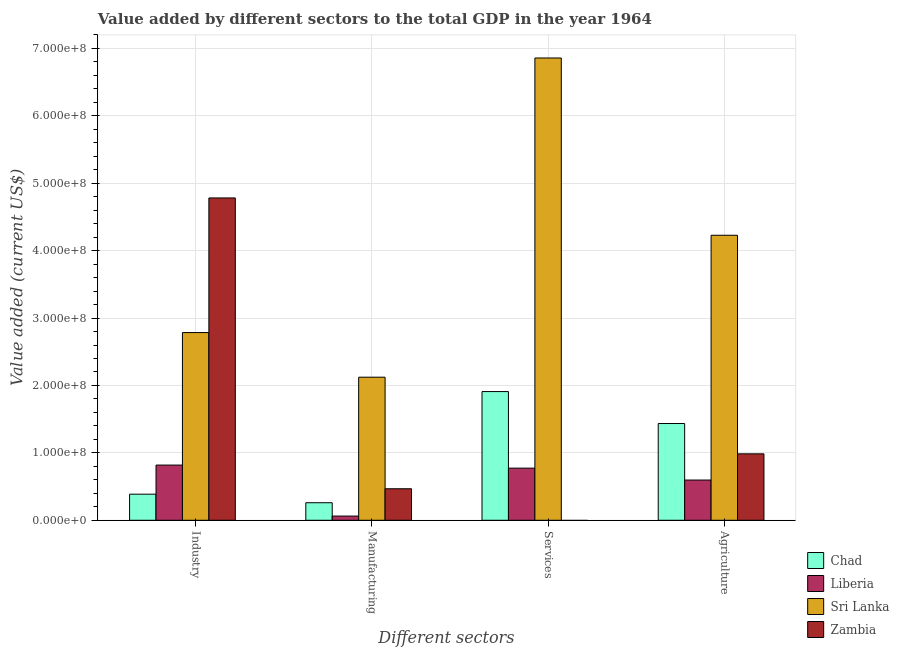How many different coloured bars are there?
Make the answer very short. 4. Are the number of bars per tick equal to the number of legend labels?
Keep it short and to the point. No. Are the number of bars on each tick of the X-axis equal?
Make the answer very short. No. How many bars are there on the 4th tick from the left?
Provide a short and direct response. 4. What is the label of the 1st group of bars from the left?
Your response must be concise. Industry. What is the value added by services sector in Zambia?
Your response must be concise. 0. Across all countries, what is the maximum value added by industrial sector?
Ensure brevity in your answer.  4.78e+08. Across all countries, what is the minimum value added by manufacturing sector?
Your response must be concise. 6.23e+06. In which country was the value added by industrial sector maximum?
Give a very brief answer. Zambia. What is the total value added by services sector in the graph?
Offer a very short reply. 9.54e+08. What is the difference between the value added by agricultural sector in Zambia and that in Chad?
Provide a short and direct response. -4.50e+07. What is the difference between the value added by services sector in Chad and the value added by manufacturing sector in Zambia?
Your answer should be very brief. 1.44e+08. What is the average value added by manufacturing sector per country?
Offer a very short reply. 7.28e+07. What is the difference between the value added by manufacturing sector and value added by industrial sector in Liberia?
Your response must be concise. -7.57e+07. What is the ratio of the value added by agricultural sector in Liberia to that in Zambia?
Offer a terse response. 0.61. Is the value added by agricultural sector in Sri Lanka less than that in Liberia?
Provide a short and direct response. No. What is the difference between the highest and the second highest value added by agricultural sector?
Offer a terse response. 2.79e+08. What is the difference between the highest and the lowest value added by manufacturing sector?
Give a very brief answer. 2.06e+08. In how many countries, is the value added by services sector greater than the average value added by services sector taken over all countries?
Your answer should be very brief. 1. Is the sum of the value added by agricultural sector in Chad and Sri Lanka greater than the maximum value added by manufacturing sector across all countries?
Ensure brevity in your answer.  Yes. Is it the case that in every country, the sum of the value added by industrial sector and value added by agricultural sector is greater than the sum of value added by services sector and value added by manufacturing sector?
Your answer should be very brief. No. How many bars are there?
Provide a short and direct response. 15. Are all the bars in the graph horizontal?
Give a very brief answer. No. Does the graph contain grids?
Offer a terse response. Yes. Where does the legend appear in the graph?
Provide a short and direct response. Bottom right. What is the title of the graph?
Your answer should be compact. Value added by different sectors to the total GDP in the year 1964. What is the label or title of the X-axis?
Give a very brief answer. Different sectors. What is the label or title of the Y-axis?
Your answer should be compact. Value added (current US$). What is the Value added (current US$) of Chad in Industry?
Your answer should be compact. 3.87e+07. What is the Value added (current US$) of Liberia in Industry?
Offer a very short reply. 8.19e+07. What is the Value added (current US$) of Sri Lanka in Industry?
Provide a succinct answer. 2.78e+08. What is the Value added (current US$) of Zambia in Industry?
Offer a terse response. 4.78e+08. What is the Value added (current US$) of Chad in Manufacturing?
Your answer should be compact. 2.60e+07. What is the Value added (current US$) of Liberia in Manufacturing?
Ensure brevity in your answer.  6.23e+06. What is the Value added (current US$) of Sri Lanka in Manufacturing?
Give a very brief answer. 2.12e+08. What is the Value added (current US$) of Zambia in Manufacturing?
Offer a terse response. 4.68e+07. What is the Value added (current US$) of Chad in Services?
Offer a very short reply. 1.91e+08. What is the Value added (current US$) of Liberia in Services?
Make the answer very short. 7.74e+07. What is the Value added (current US$) of Sri Lanka in Services?
Ensure brevity in your answer.  6.86e+08. What is the Value added (current US$) of Chad in Agriculture?
Your response must be concise. 1.44e+08. What is the Value added (current US$) of Liberia in Agriculture?
Keep it short and to the point. 5.97e+07. What is the Value added (current US$) in Sri Lanka in Agriculture?
Make the answer very short. 4.23e+08. What is the Value added (current US$) of Zambia in Agriculture?
Offer a very short reply. 9.86e+07. Across all Different sectors, what is the maximum Value added (current US$) of Chad?
Your answer should be very brief. 1.91e+08. Across all Different sectors, what is the maximum Value added (current US$) in Liberia?
Ensure brevity in your answer.  8.19e+07. Across all Different sectors, what is the maximum Value added (current US$) of Sri Lanka?
Offer a very short reply. 6.86e+08. Across all Different sectors, what is the maximum Value added (current US$) in Zambia?
Your answer should be compact. 4.78e+08. Across all Different sectors, what is the minimum Value added (current US$) of Chad?
Make the answer very short. 2.60e+07. Across all Different sectors, what is the minimum Value added (current US$) of Liberia?
Provide a short and direct response. 6.23e+06. Across all Different sectors, what is the minimum Value added (current US$) of Sri Lanka?
Offer a terse response. 2.12e+08. What is the total Value added (current US$) of Chad in the graph?
Provide a short and direct response. 3.99e+08. What is the total Value added (current US$) in Liberia in the graph?
Your answer should be compact. 2.25e+08. What is the total Value added (current US$) in Sri Lanka in the graph?
Provide a succinct answer. 1.60e+09. What is the total Value added (current US$) of Zambia in the graph?
Your answer should be very brief. 6.24e+08. What is the difference between the Value added (current US$) of Chad in Industry and that in Manufacturing?
Give a very brief answer. 1.27e+07. What is the difference between the Value added (current US$) in Liberia in Industry and that in Manufacturing?
Offer a terse response. 7.57e+07. What is the difference between the Value added (current US$) in Sri Lanka in Industry and that in Manufacturing?
Offer a very short reply. 6.62e+07. What is the difference between the Value added (current US$) in Zambia in Industry and that in Manufacturing?
Your response must be concise. 4.31e+08. What is the difference between the Value added (current US$) of Chad in Industry and that in Services?
Your answer should be compact. -1.52e+08. What is the difference between the Value added (current US$) of Liberia in Industry and that in Services?
Your answer should be very brief. 4.53e+06. What is the difference between the Value added (current US$) of Sri Lanka in Industry and that in Services?
Give a very brief answer. -4.07e+08. What is the difference between the Value added (current US$) in Chad in Industry and that in Agriculture?
Your answer should be compact. -1.05e+08. What is the difference between the Value added (current US$) of Liberia in Industry and that in Agriculture?
Offer a very short reply. 2.22e+07. What is the difference between the Value added (current US$) of Sri Lanka in Industry and that in Agriculture?
Your answer should be compact. -1.44e+08. What is the difference between the Value added (current US$) of Zambia in Industry and that in Agriculture?
Your answer should be very brief. 3.80e+08. What is the difference between the Value added (current US$) in Chad in Manufacturing and that in Services?
Your response must be concise. -1.65e+08. What is the difference between the Value added (current US$) in Liberia in Manufacturing and that in Services?
Provide a succinct answer. -7.11e+07. What is the difference between the Value added (current US$) in Sri Lanka in Manufacturing and that in Services?
Your answer should be compact. -4.74e+08. What is the difference between the Value added (current US$) in Chad in Manufacturing and that in Agriculture?
Give a very brief answer. -1.18e+08. What is the difference between the Value added (current US$) in Liberia in Manufacturing and that in Agriculture?
Give a very brief answer. -5.35e+07. What is the difference between the Value added (current US$) of Sri Lanka in Manufacturing and that in Agriculture?
Make the answer very short. -2.11e+08. What is the difference between the Value added (current US$) of Zambia in Manufacturing and that in Agriculture?
Offer a terse response. -5.18e+07. What is the difference between the Value added (current US$) in Chad in Services and that in Agriculture?
Your answer should be very brief. 4.74e+07. What is the difference between the Value added (current US$) in Liberia in Services and that in Agriculture?
Your answer should be compact. 1.77e+07. What is the difference between the Value added (current US$) of Sri Lanka in Services and that in Agriculture?
Make the answer very short. 2.63e+08. What is the difference between the Value added (current US$) in Chad in Industry and the Value added (current US$) in Liberia in Manufacturing?
Make the answer very short. 3.25e+07. What is the difference between the Value added (current US$) of Chad in Industry and the Value added (current US$) of Sri Lanka in Manufacturing?
Give a very brief answer. -1.74e+08. What is the difference between the Value added (current US$) of Chad in Industry and the Value added (current US$) of Zambia in Manufacturing?
Keep it short and to the point. -8.06e+06. What is the difference between the Value added (current US$) of Liberia in Industry and the Value added (current US$) of Sri Lanka in Manufacturing?
Your answer should be very brief. -1.30e+08. What is the difference between the Value added (current US$) in Liberia in Industry and the Value added (current US$) in Zambia in Manufacturing?
Make the answer very short. 3.51e+07. What is the difference between the Value added (current US$) of Sri Lanka in Industry and the Value added (current US$) of Zambia in Manufacturing?
Your answer should be very brief. 2.32e+08. What is the difference between the Value added (current US$) of Chad in Industry and the Value added (current US$) of Liberia in Services?
Keep it short and to the point. -3.87e+07. What is the difference between the Value added (current US$) of Chad in Industry and the Value added (current US$) of Sri Lanka in Services?
Your answer should be compact. -6.47e+08. What is the difference between the Value added (current US$) of Liberia in Industry and the Value added (current US$) of Sri Lanka in Services?
Offer a terse response. -6.04e+08. What is the difference between the Value added (current US$) of Chad in Industry and the Value added (current US$) of Liberia in Agriculture?
Your response must be concise. -2.10e+07. What is the difference between the Value added (current US$) of Chad in Industry and the Value added (current US$) of Sri Lanka in Agriculture?
Keep it short and to the point. -3.84e+08. What is the difference between the Value added (current US$) in Chad in Industry and the Value added (current US$) in Zambia in Agriculture?
Provide a succinct answer. -5.99e+07. What is the difference between the Value added (current US$) in Liberia in Industry and the Value added (current US$) in Sri Lanka in Agriculture?
Provide a short and direct response. -3.41e+08. What is the difference between the Value added (current US$) of Liberia in Industry and the Value added (current US$) of Zambia in Agriculture?
Offer a very short reply. -1.67e+07. What is the difference between the Value added (current US$) in Sri Lanka in Industry and the Value added (current US$) in Zambia in Agriculture?
Ensure brevity in your answer.  1.80e+08. What is the difference between the Value added (current US$) of Chad in Manufacturing and the Value added (current US$) of Liberia in Services?
Keep it short and to the point. -5.13e+07. What is the difference between the Value added (current US$) of Chad in Manufacturing and the Value added (current US$) of Sri Lanka in Services?
Offer a very short reply. -6.60e+08. What is the difference between the Value added (current US$) of Liberia in Manufacturing and the Value added (current US$) of Sri Lanka in Services?
Ensure brevity in your answer.  -6.80e+08. What is the difference between the Value added (current US$) of Chad in Manufacturing and the Value added (current US$) of Liberia in Agriculture?
Make the answer very short. -3.37e+07. What is the difference between the Value added (current US$) of Chad in Manufacturing and the Value added (current US$) of Sri Lanka in Agriculture?
Give a very brief answer. -3.97e+08. What is the difference between the Value added (current US$) of Chad in Manufacturing and the Value added (current US$) of Zambia in Agriculture?
Provide a succinct answer. -7.25e+07. What is the difference between the Value added (current US$) in Liberia in Manufacturing and the Value added (current US$) in Sri Lanka in Agriculture?
Your answer should be very brief. -4.17e+08. What is the difference between the Value added (current US$) in Liberia in Manufacturing and the Value added (current US$) in Zambia in Agriculture?
Offer a terse response. -9.23e+07. What is the difference between the Value added (current US$) in Sri Lanka in Manufacturing and the Value added (current US$) in Zambia in Agriculture?
Ensure brevity in your answer.  1.14e+08. What is the difference between the Value added (current US$) in Chad in Services and the Value added (current US$) in Liberia in Agriculture?
Ensure brevity in your answer.  1.31e+08. What is the difference between the Value added (current US$) in Chad in Services and the Value added (current US$) in Sri Lanka in Agriculture?
Keep it short and to the point. -2.32e+08. What is the difference between the Value added (current US$) in Chad in Services and the Value added (current US$) in Zambia in Agriculture?
Your answer should be compact. 9.24e+07. What is the difference between the Value added (current US$) of Liberia in Services and the Value added (current US$) of Sri Lanka in Agriculture?
Make the answer very short. -3.45e+08. What is the difference between the Value added (current US$) of Liberia in Services and the Value added (current US$) of Zambia in Agriculture?
Provide a succinct answer. -2.12e+07. What is the difference between the Value added (current US$) in Sri Lanka in Services and the Value added (current US$) in Zambia in Agriculture?
Your answer should be compact. 5.87e+08. What is the average Value added (current US$) in Chad per Different sectors?
Your answer should be compact. 9.98e+07. What is the average Value added (current US$) of Liberia per Different sectors?
Your answer should be very brief. 5.63e+07. What is the average Value added (current US$) of Sri Lanka per Different sectors?
Make the answer very short. 4.00e+08. What is the average Value added (current US$) of Zambia per Different sectors?
Your answer should be very brief. 1.56e+08. What is the difference between the Value added (current US$) of Chad and Value added (current US$) of Liberia in Industry?
Provide a short and direct response. -4.32e+07. What is the difference between the Value added (current US$) in Chad and Value added (current US$) in Sri Lanka in Industry?
Your answer should be very brief. -2.40e+08. What is the difference between the Value added (current US$) of Chad and Value added (current US$) of Zambia in Industry?
Provide a short and direct response. -4.40e+08. What is the difference between the Value added (current US$) of Liberia and Value added (current US$) of Sri Lanka in Industry?
Give a very brief answer. -1.97e+08. What is the difference between the Value added (current US$) of Liberia and Value added (current US$) of Zambia in Industry?
Offer a terse response. -3.96e+08. What is the difference between the Value added (current US$) in Sri Lanka and Value added (current US$) in Zambia in Industry?
Offer a very short reply. -2.00e+08. What is the difference between the Value added (current US$) of Chad and Value added (current US$) of Liberia in Manufacturing?
Offer a terse response. 1.98e+07. What is the difference between the Value added (current US$) in Chad and Value added (current US$) in Sri Lanka in Manufacturing?
Offer a very short reply. -1.86e+08. What is the difference between the Value added (current US$) of Chad and Value added (current US$) of Zambia in Manufacturing?
Your response must be concise. -2.07e+07. What is the difference between the Value added (current US$) in Liberia and Value added (current US$) in Sri Lanka in Manufacturing?
Your answer should be compact. -2.06e+08. What is the difference between the Value added (current US$) in Liberia and Value added (current US$) in Zambia in Manufacturing?
Your answer should be compact. -4.05e+07. What is the difference between the Value added (current US$) in Sri Lanka and Value added (current US$) in Zambia in Manufacturing?
Give a very brief answer. 1.66e+08. What is the difference between the Value added (current US$) of Chad and Value added (current US$) of Liberia in Services?
Provide a short and direct response. 1.14e+08. What is the difference between the Value added (current US$) in Chad and Value added (current US$) in Sri Lanka in Services?
Make the answer very short. -4.95e+08. What is the difference between the Value added (current US$) in Liberia and Value added (current US$) in Sri Lanka in Services?
Your answer should be very brief. -6.09e+08. What is the difference between the Value added (current US$) of Chad and Value added (current US$) of Liberia in Agriculture?
Keep it short and to the point. 8.38e+07. What is the difference between the Value added (current US$) in Chad and Value added (current US$) in Sri Lanka in Agriculture?
Provide a short and direct response. -2.79e+08. What is the difference between the Value added (current US$) of Chad and Value added (current US$) of Zambia in Agriculture?
Provide a short and direct response. 4.50e+07. What is the difference between the Value added (current US$) of Liberia and Value added (current US$) of Sri Lanka in Agriculture?
Your answer should be very brief. -3.63e+08. What is the difference between the Value added (current US$) in Liberia and Value added (current US$) in Zambia in Agriculture?
Provide a succinct answer. -3.89e+07. What is the difference between the Value added (current US$) in Sri Lanka and Value added (current US$) in Zambia in Agriculture?
Ensure brevity in your answer.  3.24e+08. What is the ratio of the Value added (current US$) of Chad in Industry to that in Manufacturing?
Keep it short and to the point. 1.49. What is the ratio of the Value added (current US$) of Liberia in Industry to that in Manufacturing?
Provide a succinct answer. 13.14. What is the ratio of the Value added (current US$) of Sri Lanka in Industry to that in Manufacturing?
Offer a very short reply. 1.31. What is the ratio of the Value added (current US$) of Zambia in Industry to that in Manufacturing?
Your answer should be very brief. 10.23. What is the ratio of the Value added (current US$) of Chad in Industry to that in Services?
Give a very brief answer. 0.2. What is the ratio of the Value added (current US$) of Liberia in Industry to that in Services?
Your answer should be very brief. 1.06. What is the ratio of the Value added (current US$) of Sri Lanka in Industry to that in Services?
Offer a terse response. 0.41. What is the ratio of the Value added (current US$) in Chad in Industry to that in Agriculture?
Give a very brief answer. 0.27. What is the ratio of the Value added (current US$) in Liberia in Industry to that in Agriculture?
Offer a terse response. 1.37. What is the ratio of the Value added (current US$) of Sri Lanka in Industry to that in Agriculture?
Provide a short and direct response. 0.66. What is the ratio of the Value added (current US$) of Zambia in Industry to that in Agriculture?
Give a very brief answer. 4.85. What is the ratio of the Value added (current US$) of Chad in Manufacturing to that in Services?
Ensure brevity in your answer.  0.14. What is the ratio of the Value added (current US$) in Liberia in Manufacturing to that in Services?
Your response must be concise. 0.08. What is the ratio of the Value added (current US$) in Sri Lanka in Manufacturing to that in Services?
Provide a succinct answer. 0.31. What is the ratio of the Value added (current US$) of Chad in Manufacturing to that in Agriculture?
Keep it short and to the point. 0.18. What is the ratio of the Value added (current US$) of Liberia in Manufacturing to that in Agriculture?
Give a very brief answer. 0.1. What is the ratio of the Value added (current US$) of Sri Lanka in Manufacturing to that in Agriculture?
Provide a short and direct response. 0.5. What is the ratio of the Value added (current US$) in Zambia in Manufacturing to that in Agriculture?
Keep it short and to the point. 0.47. What is the ratio of the Value added (current US$) of Chad in Services to that in Agriculture?
Offer a very short reply. 1.33. What is the ratio of the Value added (current US$) of Liberia in Services to that in Agriculture?
Your answer should be very brief. 1.3. What is the ratio of the Value added (current US$) in Sri Lanka in Services to that in Agriculture?
Keep it short and to the point. 1.62. What is the difference between the highest and the second highest Value added (current US$) in Chad?
Provide a succinct answer. 4.74e+07. What is the difference between the highest and the second highest Value added (current US$) in Liberia?
Your answer should be compact. 4.53e+06. What is the difference between the highest and the second highest Value added (current US$) in Sri Lanka?
Offer a very short reply. 2.63e+08. What is the difference between the highest and the second highest Value added (current US$) in Zambia?
Ensure brevity in your answer.  3.80e+08. What is the difference between the highest and the lowest Value added (current US$) in Chad?
Offer a terse response. 1.65e+08. What is the difference between the highest and the lowest Value added (current US$) in Liberia?
Make the answer very short. 7.57e+07. What is the difference between the highest and the lowest Value added (current US$) in Sri Lanka?
Keep it short and to the point. 4.74e+08. What is the difference between the highest and the lowest Value added (current US$) in Zambia?
Your answer should be compact. 4.78e+08. 